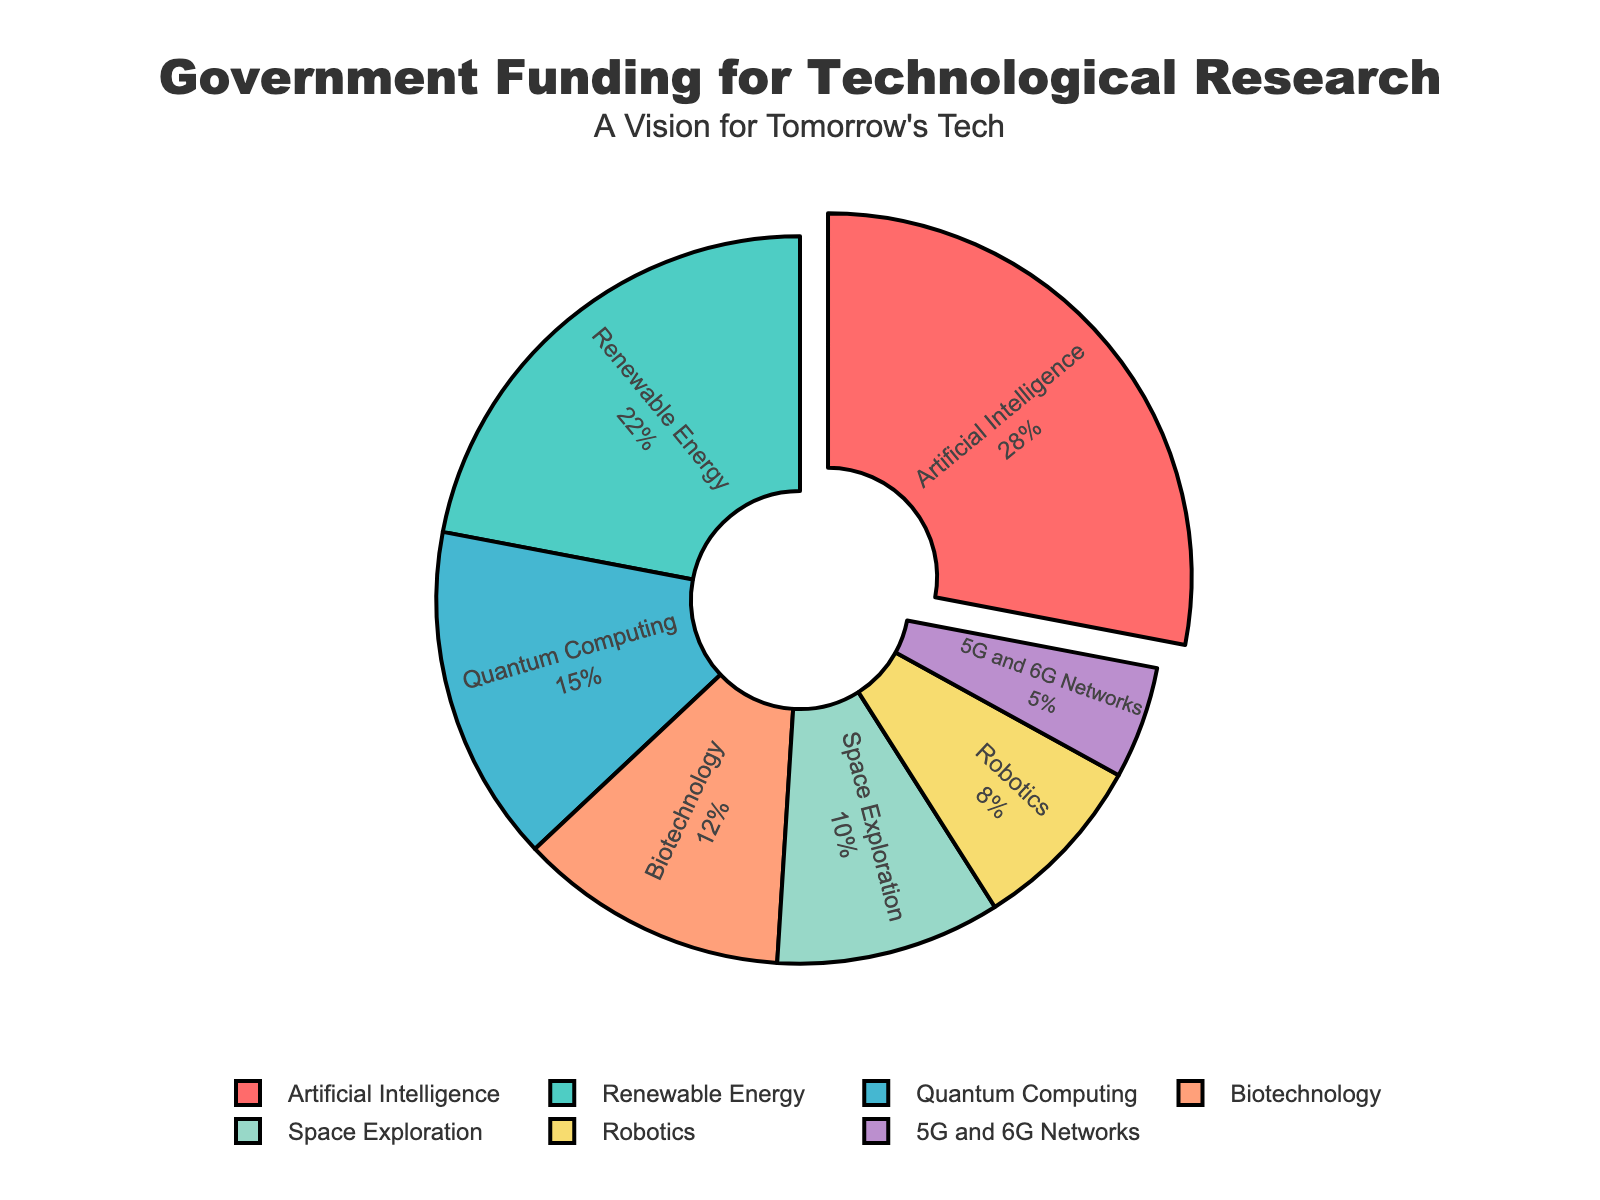Which research area receives the highest funding allocation? The pie chart depicts the percentage of government funding for each research area. By observing the chart, the research area with the largest section is labeled "Artificial Intelligence".
Answer: Artificial Intelligence What is the combined funding percentage for Biotechnology and Robotics? To find the combined funding percentage, add the given funding percentages for Biotechnology (12%) and Robotics (8%).
Answer: 20% How much more funding does Artificial Intelligence receive compared to Space Exploration? To find the difference, subtract the funding percentage for Space Exploration (10%) from that of Artificial Intelligence (28%).
Answer: 18% Which research areas have a funding percentage below 10%? By examining the pie chart, the segments for Robotics (8%) and 5G/6G Networks (5%) are each below 10% funding.
Answer: Robotics and 5G/6G Networks What is the total funding percentage allocated to Artificial Intelligence, Renewable Energy, and Quantum Computing? To find the total funding percentage, add the percentages for Artificial Intelligence (28%), Renewable Energy (22%), and Quantum Computing (15%).
Answer: 65% How does funding for Space Exploration compare to that for Biotechnology? From the chart, Space Exploration receives 10% funding, and Biotechnology receives 12%. Thus, Biotechnology receives more funding than Space Exploration.
Answer: Biotechnology receives more funding If funding for Artificial Intelligence were to increase by 5%, what would its new funding percentage be? Starting with the current funding for Artificial Intelligence at 28%, adding 5% to this amount results in 28% + 5% = 33%.
Answer: 33% Among the categories shown, which has the smallest funding allocation? By observing the smallest segment in the pie chart, the category with the least funding is 5G/6G Networks at 5%.
Answer: 5G/6G Networks 